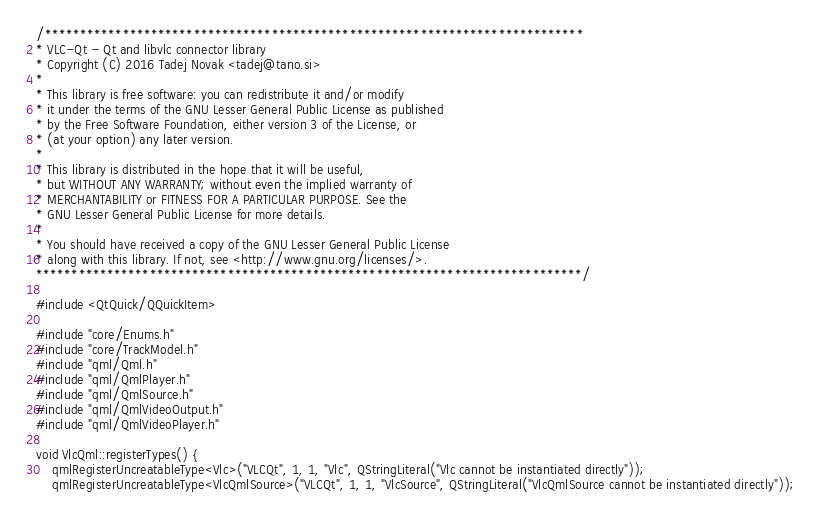Convert code to text. <code><loc_0><loc_0><loc_500><loc_500><_C++_>/****************************************************************************
* VLC-Qt - Qt and libvlc connector library
* Copyright (C) 2016 Tadej Novak <tadej@tano.si>
*
* This library is free software: you can redistribute it and/or modify
* it under the terms of the GNU Lesser General Public License as published
* by the Free Software Foundation, either version 3 of the License, or
* (at your option) any later version.
*
* This library is distributed in the hope that it will be useful,
* but WITHOUT ANY WARRANTY; without even the implied warranty of
* MERCHANTABILITY or FITNESS FOR A PARTICULAR PURPOSE. See the
* GNU Lesser General Public License for more details.
*
* You should have received a copy of the GNU Lesser General Public License
* along with this library. If not, see <http://www.gnu.org/licenses/>.
*****************************************************************************/

#include <QtQuick/QQuickItem>

#include "core/Enums.h"
#include "core/TrackModel.h"
#include "qml/Qml.h"
#include "qml/QmlPlayer.h"
#include "qml/QmlSource.h"
#include "qml/QmlVideoOutput.h"
#include "qml/QmlVideoPlayer.h"

void VlcQml::registerTypes() {
    qmlRegisterUncreatableType<Vlc>("VLCQt", 1, 1, "Vlc", QStringLiteral("Vlc cannot be instantiated directly"));
    qmlRegisterUncreatableType<VlcQmlSource>("VLCQt", 1, 1, "VlcSource", QStringLiteral("VlcQmlSource cannot be instantiated directly"));</code> 